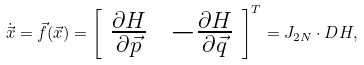<formula> <loc_0><loc_0><loc_500><loc_500>\dot { \vec { x } } = \vec { f } ( \vec { x } ) = \left [ \begin{array} { c c } \frac { \partial H } { \partial \vec { p } } \, & - \frac { \partial H } { \partial \vec { q } } \end{array} \right ] ^ { T } = J _ { 2 N } \cdot D H ,</formula> 